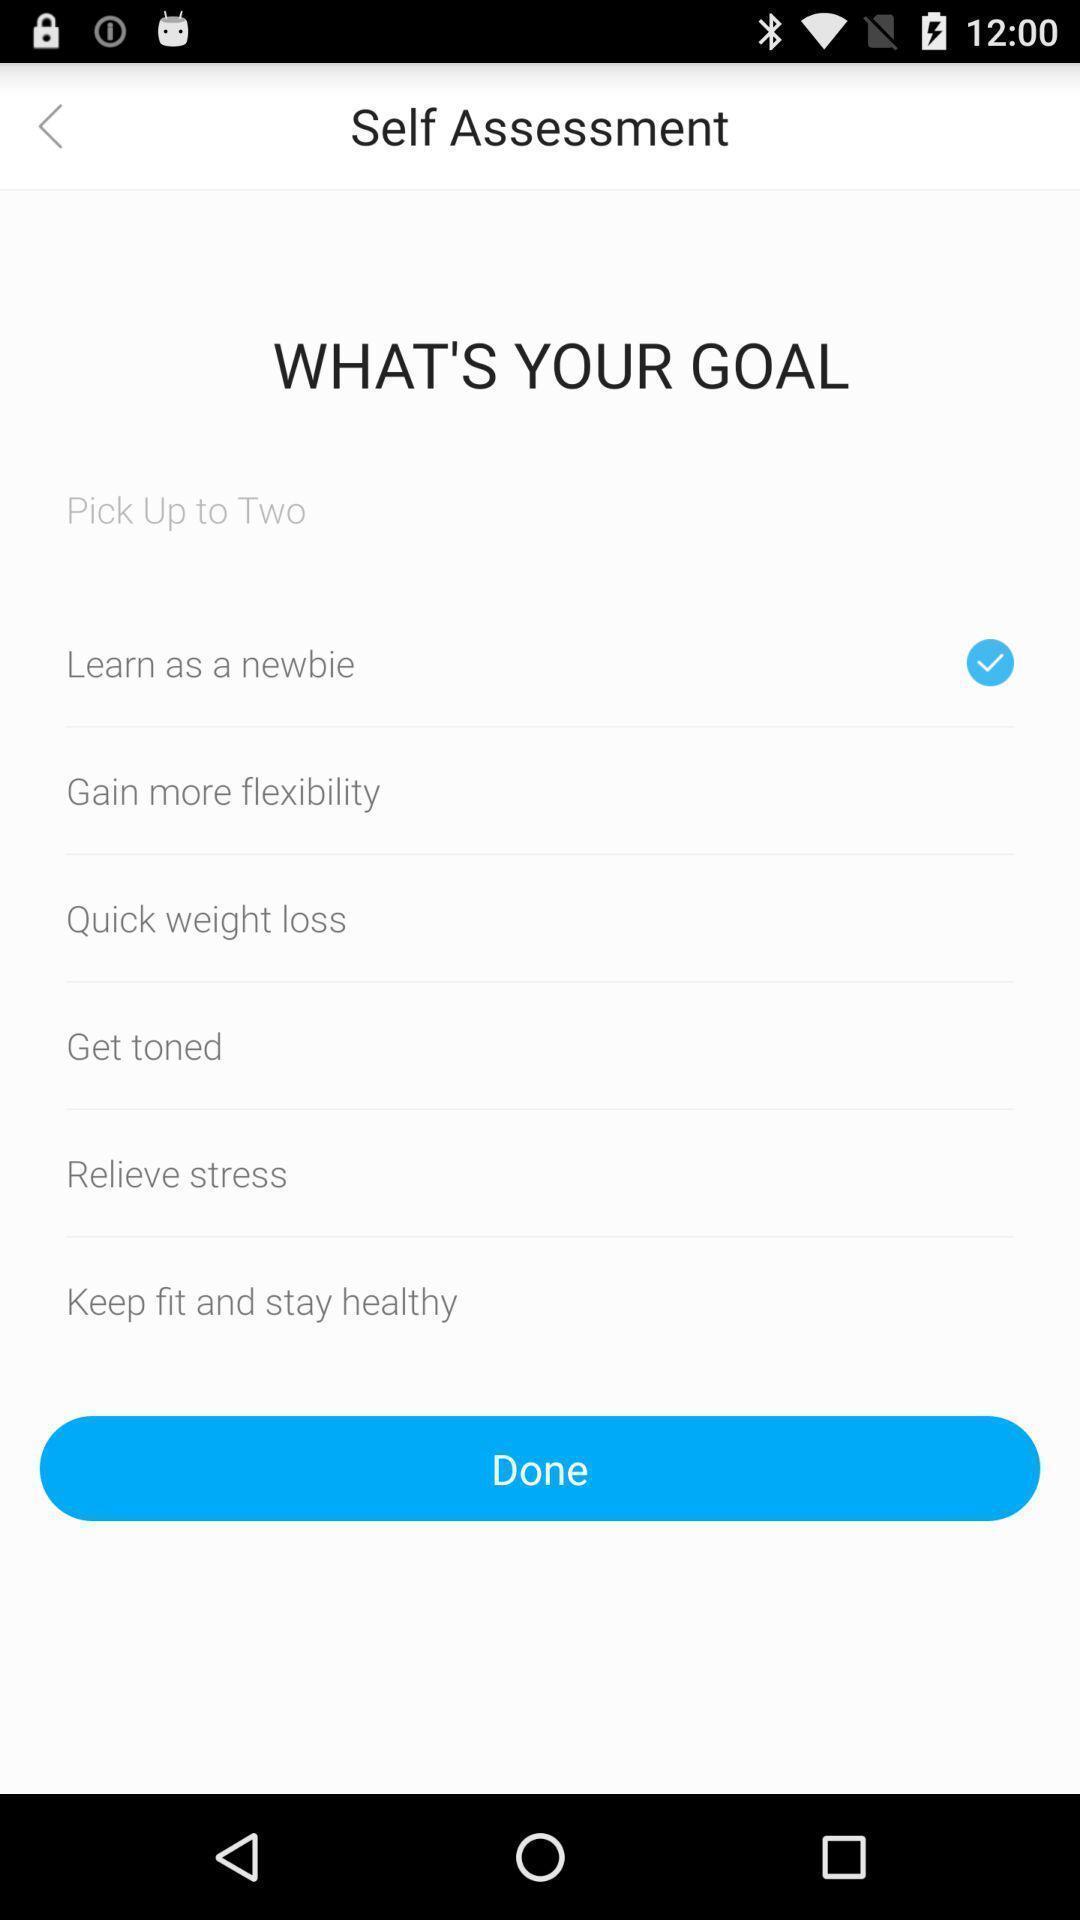Please provide a description for this image. Screen showing self assessment page in fitness app. 